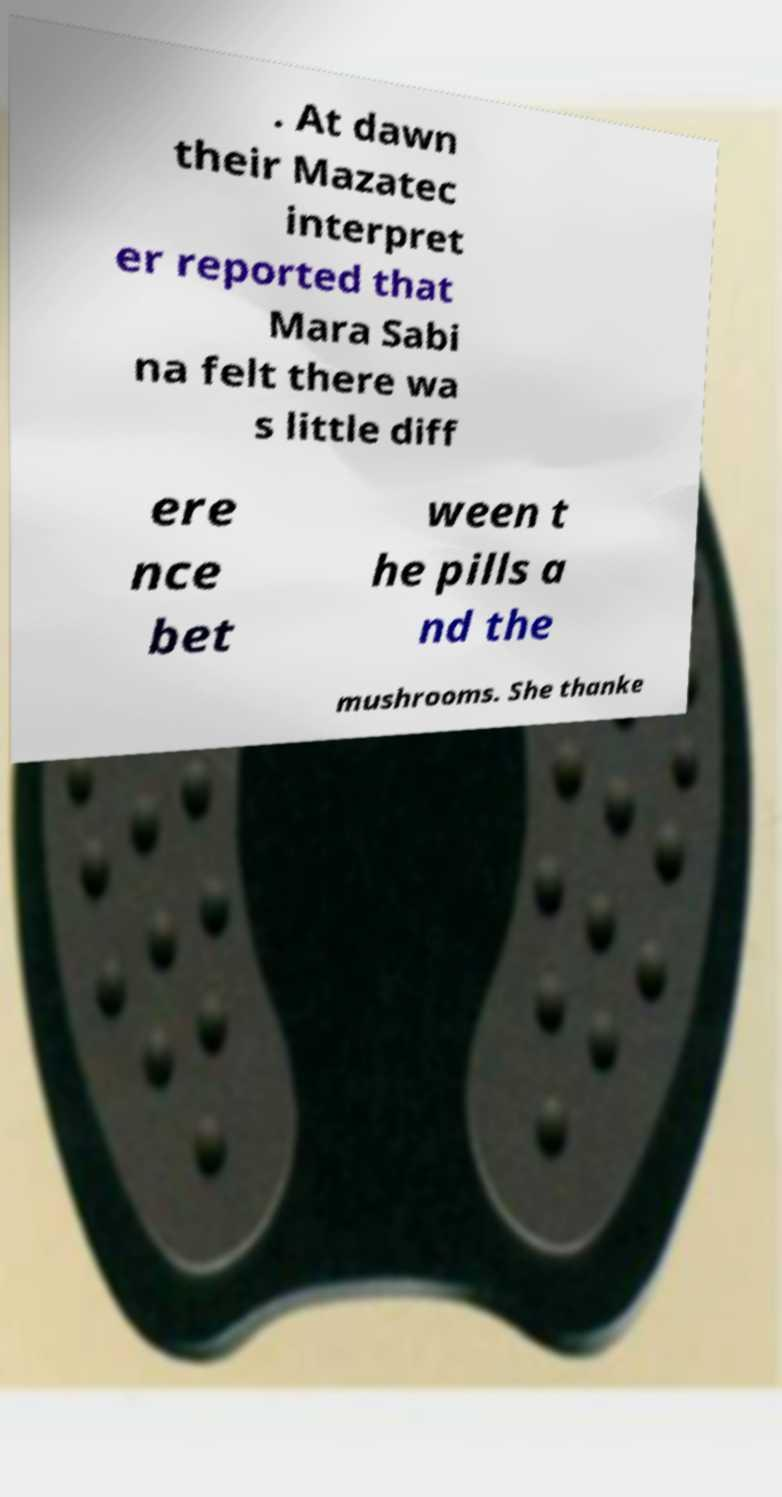I need the written content from this picture converted into text. Can you do that? . At dawn their Mazatec interpret er reported that Mara Sabi na felt there wa s little diff ere nce bet ween t he pills a nd the mushrooms. She thanke 